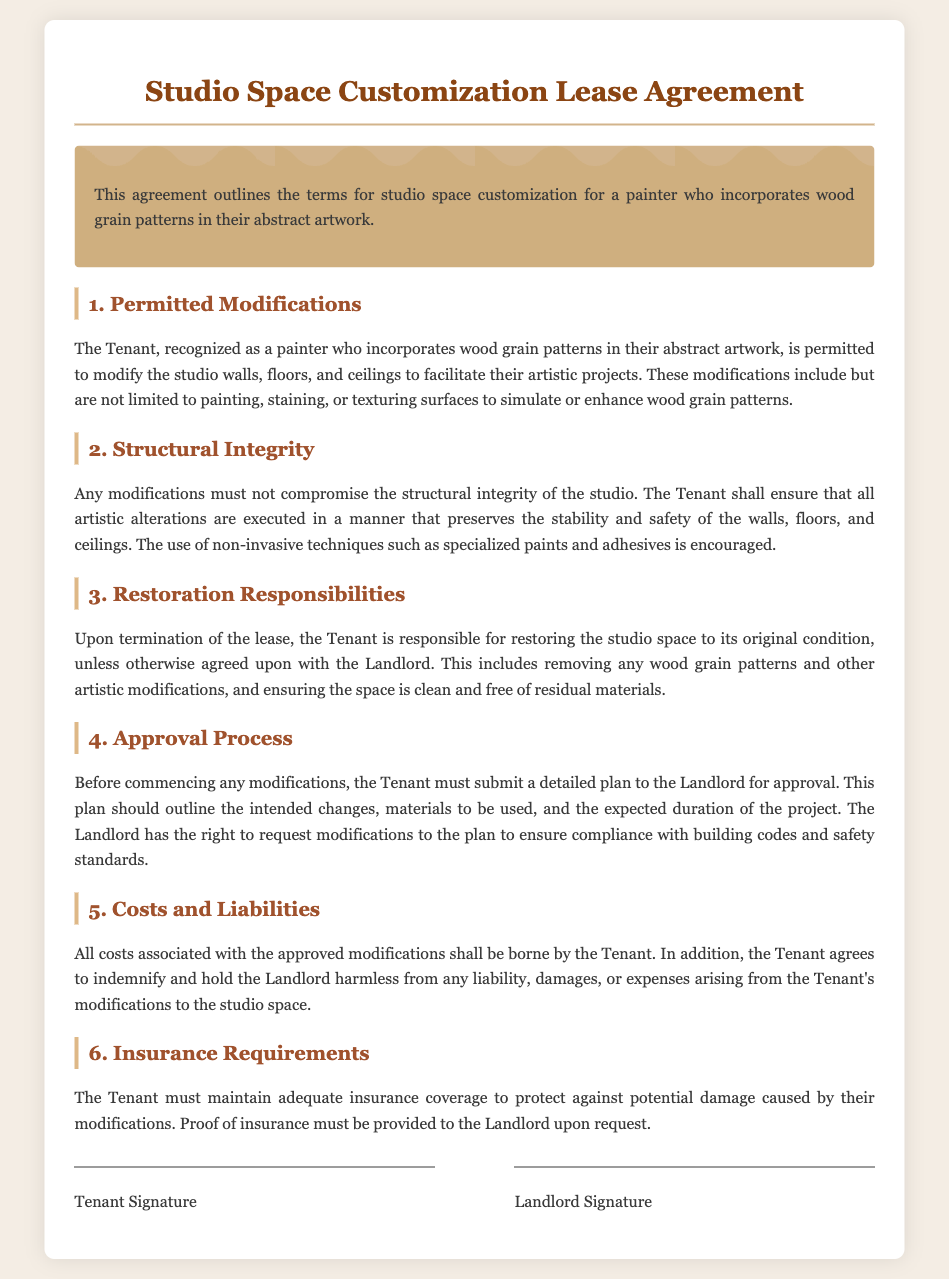What are the permitted modifications? The modifications include painting, staining, or texturing surfaces to simulate or enhance wood grain patterns.
Answer: Painting, staining, or texturing surfaces What must the Tenant ensure regarding structural integrity? The Tenant must ensure that all artistic alterations preserve the stability and safety of the walls, floors, and ceilings.
Answer: Stability and safety What is the Tenant's responsibility upon termination of the lease? The Tenant is responsible for restoring the studio space to its original condition, unless otherwise agreed upon with the Landlord.
Answer: Restoring to original condition What must the Tenant submit before commencing modifications? The Tenant must submit a detailed plan to the Landlord for approval.
Answer: Detailed plan Who bears the costs associated with approved modifications? All costs associated with the approved modifications shall be borne by the Tenant.
Answer: Tenant 